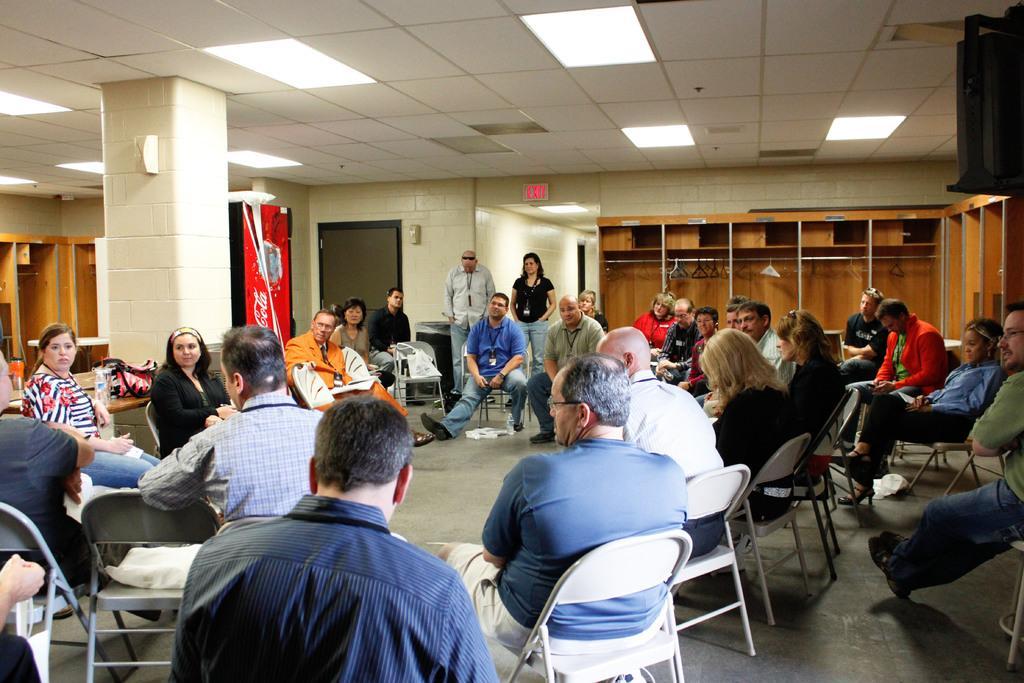Could you give a brief overview of what you see in this image? As we can see in the image there is a white color wall, few people standing and sitting here and there and there are chairs. 